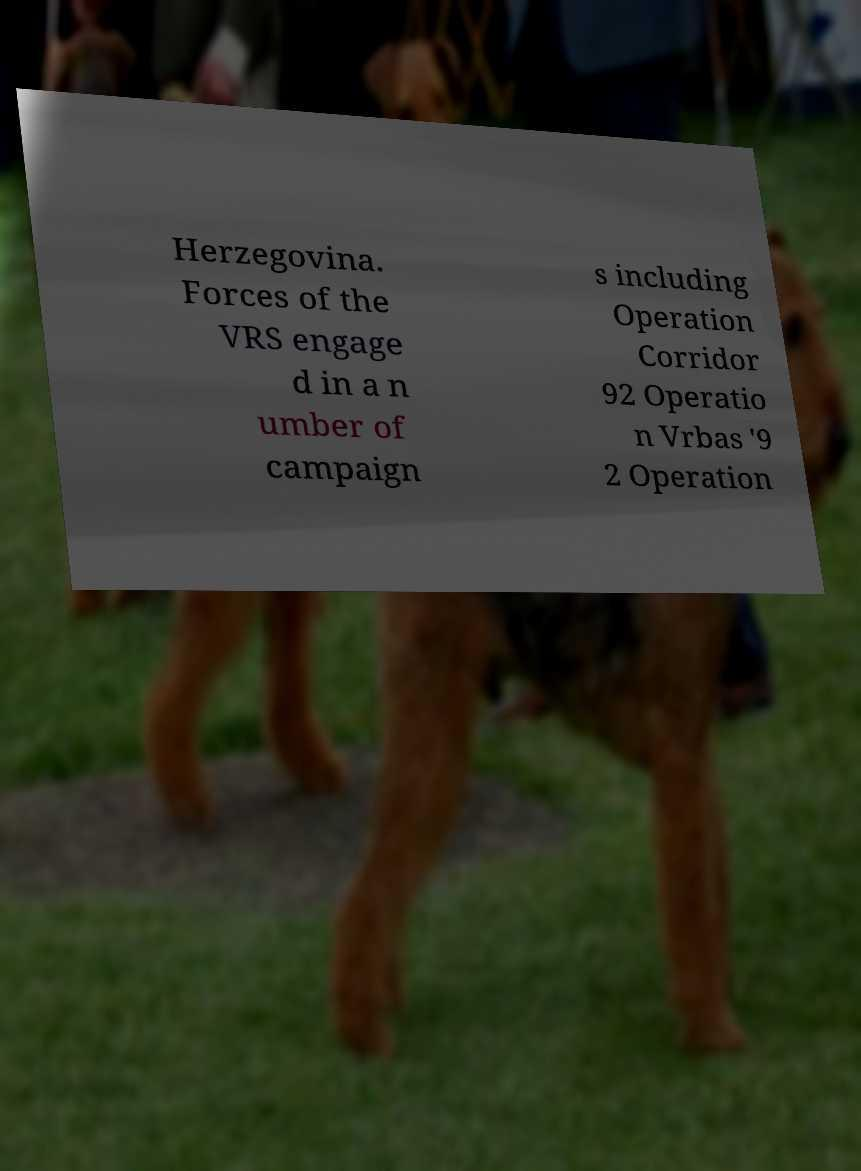There's text embedded in this image that I need extracted. Can you transcribe it verbatim? Herzegovina. Forces of the VRS engage d in a n umber of campaign s including Operation Corridor 92 Operatio n Vrbas '9 2 Operation 